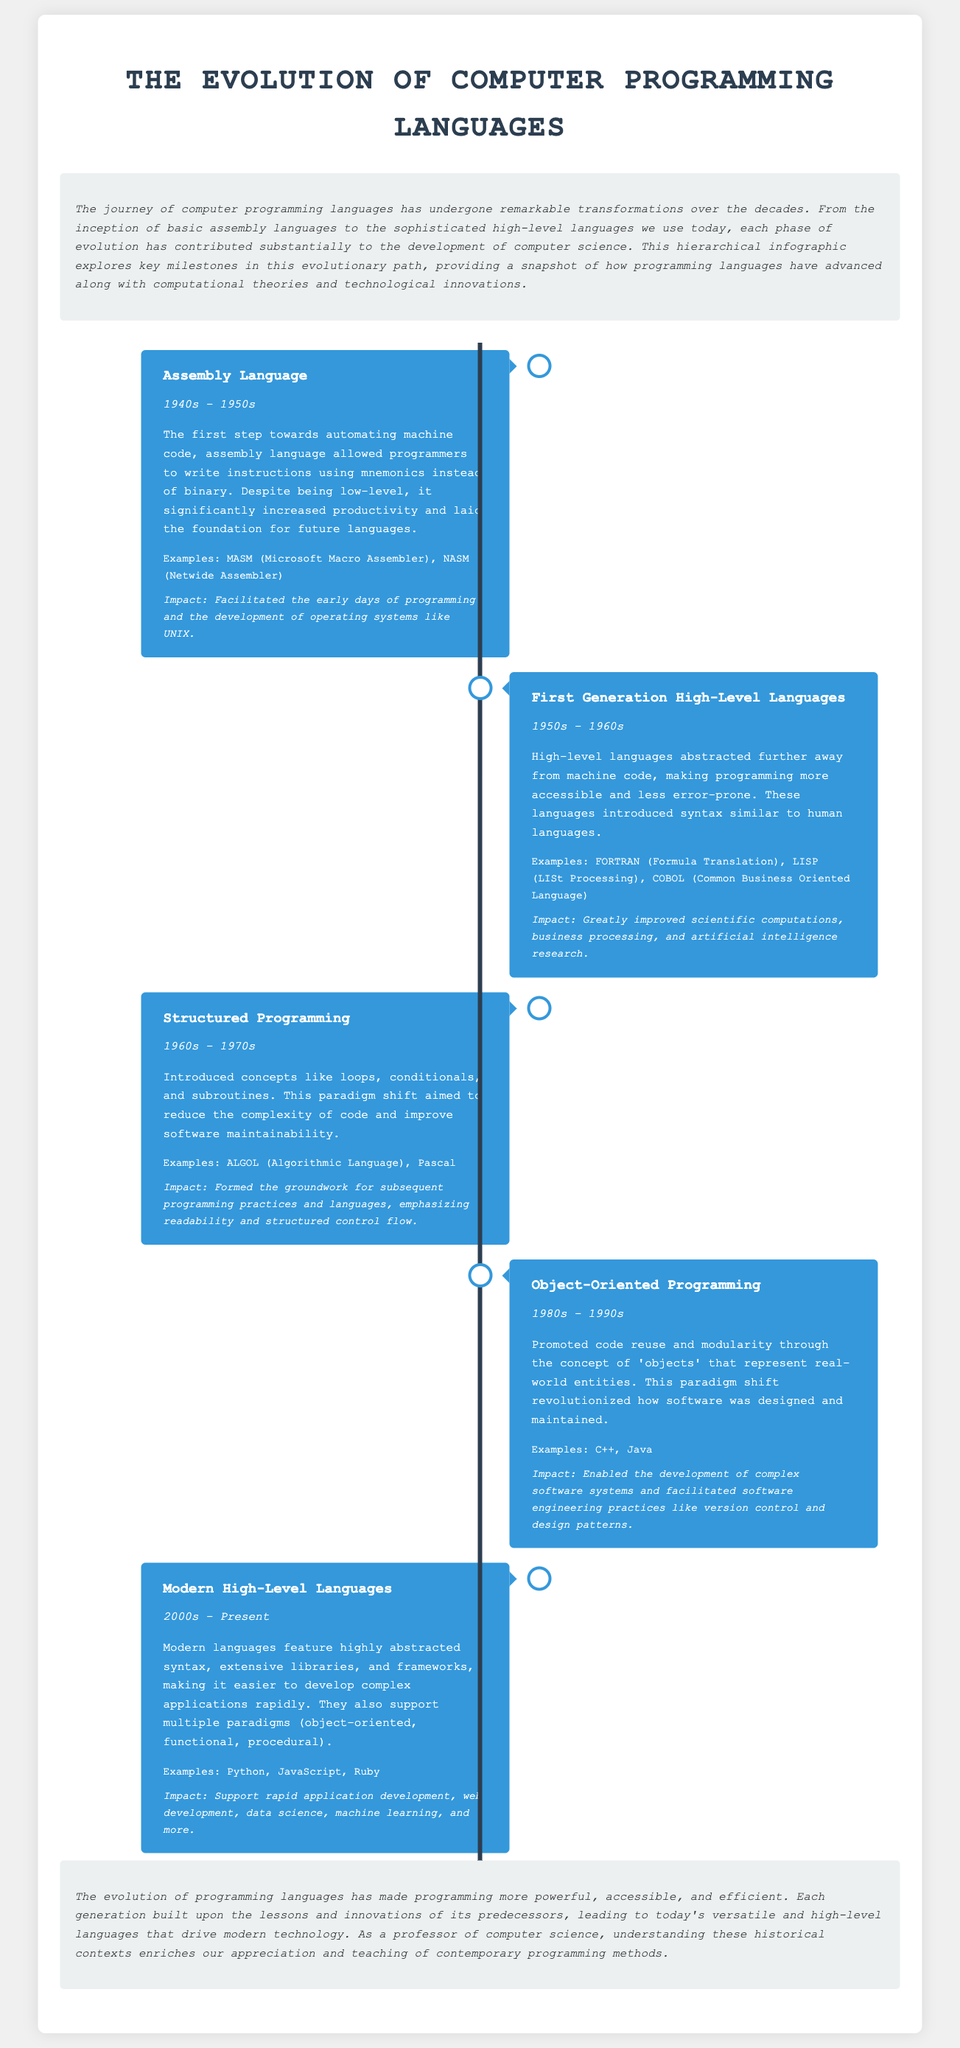What was the first programming language discussed? The document lists the first programming language as Assembly Language, which was introduced in the 1940s - 1950s.
Answer: Assembly Language What is the time period for Modern High-Level Languages? Modern High-Level Languages are defined as having emerged from the 2000s to the present.
Answer: 2000s - Present Which programming paradigm was introduced in the 1960s - 1970s? The document specifies that Structured Programming was introduced during this time period.
Answer: Structured Programming What are two examples of First Generation High-Level Languages? The document lists FORTRAN and LISP as examples of First Generation High-Level Languages.
Answer: FORTRAN, LISP What impact did Object-Oriented Programming have? The impact of Object-Oriented Programming was the enabled development of complex software systems and enhanced software engineering practices.
Answer: Enabled the development of complex software systems Why was assembly language significant? Assembly language allowed programmers to write instructions using mnemonics instead of binary, increasing productivity.
Answer: Increased productivity Which programming language category uses extensive libraries and frameworks? The document indicates that Modern High-Level Languages use extensive libraries and frameworks for application development.
Answer: Modern High-Level Languages What key concept did Structured Programming emphasize? Structured Programming emphasized readability and structured control flow.
Answer: Readability and structured control flow What does the conclusion indicate about programming language evolution? The conclusion emphasizes that programming languages have become more powerful, accessible, and efficient over time.
Answer: More powerful, accessible, and efficient 